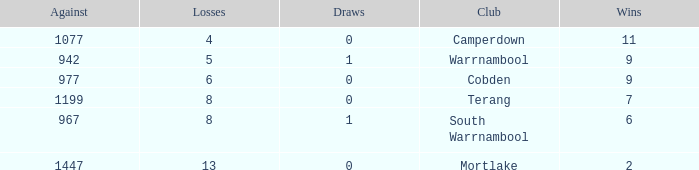Could you parse the entire table as a dict? {'header': ['Against', 'Losses', 'Draws', 'Club', 'Wins'], 'rows': [['1077', '4', '0', 'Camperdown', '11'], ['942', '5', '1', 'Warrnambool', '9'], ['977', '6', '0', 'Cobden', '9'], ['1199', '8', '0', 'Terang', '7'], ['967', '8', '1', 'South Warrnambool', '6'], ['1447', '13', '0', 'Mortlake', '2']]} How many wins did Cobden have when draws were more than 0? 0.0. 